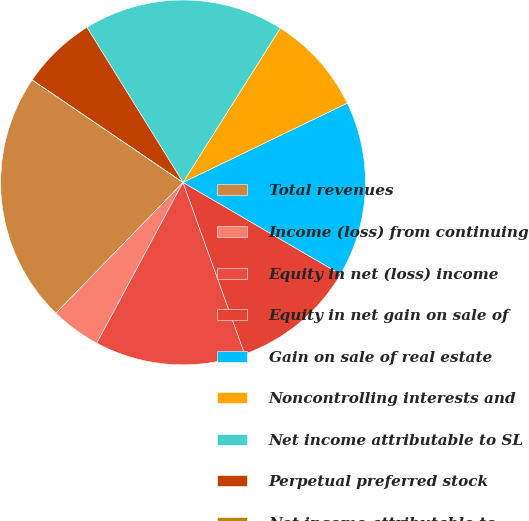Convert chart. <chart><loc_0><loc_0><loc_500><loc_500><pie_chart><fcel>Total revenues<fcel>Income (loss) from continuing<fcel>Equity in net (loss) income<fcel>Equity in net gain on sale of<fcel>Gain on sale of real estate<fcel>Noncontrolling interests and<fcel>Net income attributable to SL<fcel>Perpetual preferred stock<fcel>Net income attributable to<nl><fcel>22.22%<fcel>4.44%<fcel>13.33%<fcel>11.11%<fcel>15.56%<fcel>8.89%<fcel>17.78%<fcel>6.67%<fcel>0.0%<nl></chart> 